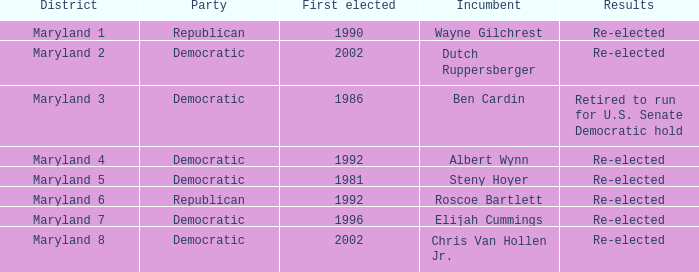What are the results of the incumbent who was first elected in 1996? Re-elected. 